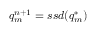Convert formula to latex. <formula><loc_0><loc_0><loc_500><loc_500>q _ { m } ^ { n + 1 } = s s d ( q _ { m } ^ { * } )</formula> 